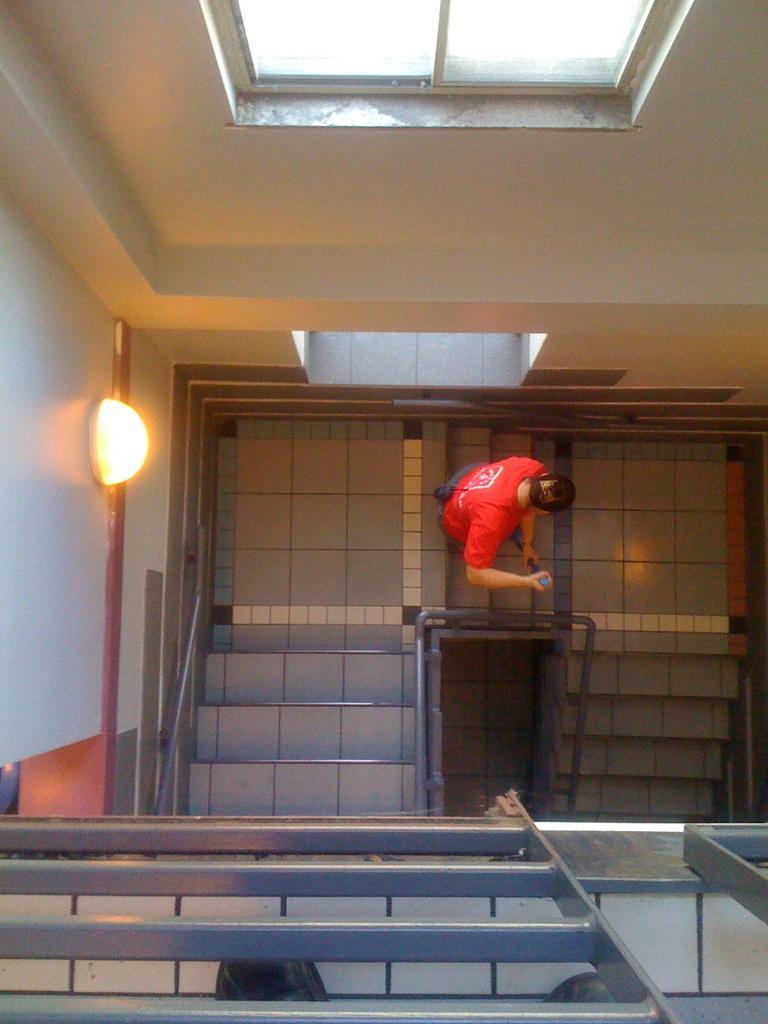In one or two sentences, can you explain what this image depicts? In this picture I can see a human holding a stick in his hands and I can see stairs and I can see a light on the wall. 